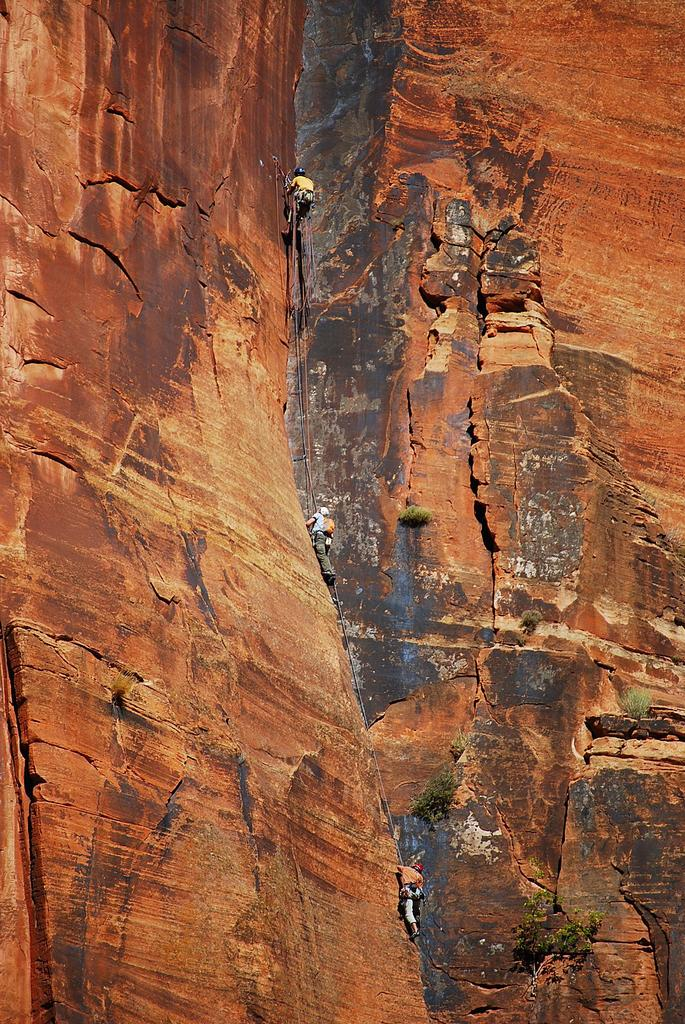How many people are in the image? There are three persons in the image. What are the persons doing in the image? The persons are climbing a mountain. What type of quiver can be seen on the mountain in the image? There is no quiver present in the image; it features three persons climbing a mountain. What kind of cream is being applied to the mountain by the persons in the image? There is no cream being applied to the mountain by the persons in the image; they are simply climbing it. 